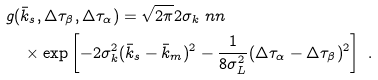Convert formula to latex. <formula><loc_0><loc_0><loc_500><loc_500>& g ( \bar { k } _ { s } , \Delta \tau _ { \beta } , \Delta \tau _ { \alpha } ) = \sqrt { 2 \pi } 2 \sigma _ { k } \ n n \\ & \quad \times \exp \left [ - 2 \sigma ^ { 2 } _ { k } ( \bar { k } _ { s } - \bar { k } _ { m } ) ^ { 2 } - \frac { 1 } { 8 \sigma ^ { 2 } _ { L } } ( \Delta \tau _ { \alpha } - \Delta \tau _ { \beta } ) ^ { 2 } \right ] \ .</formula> 